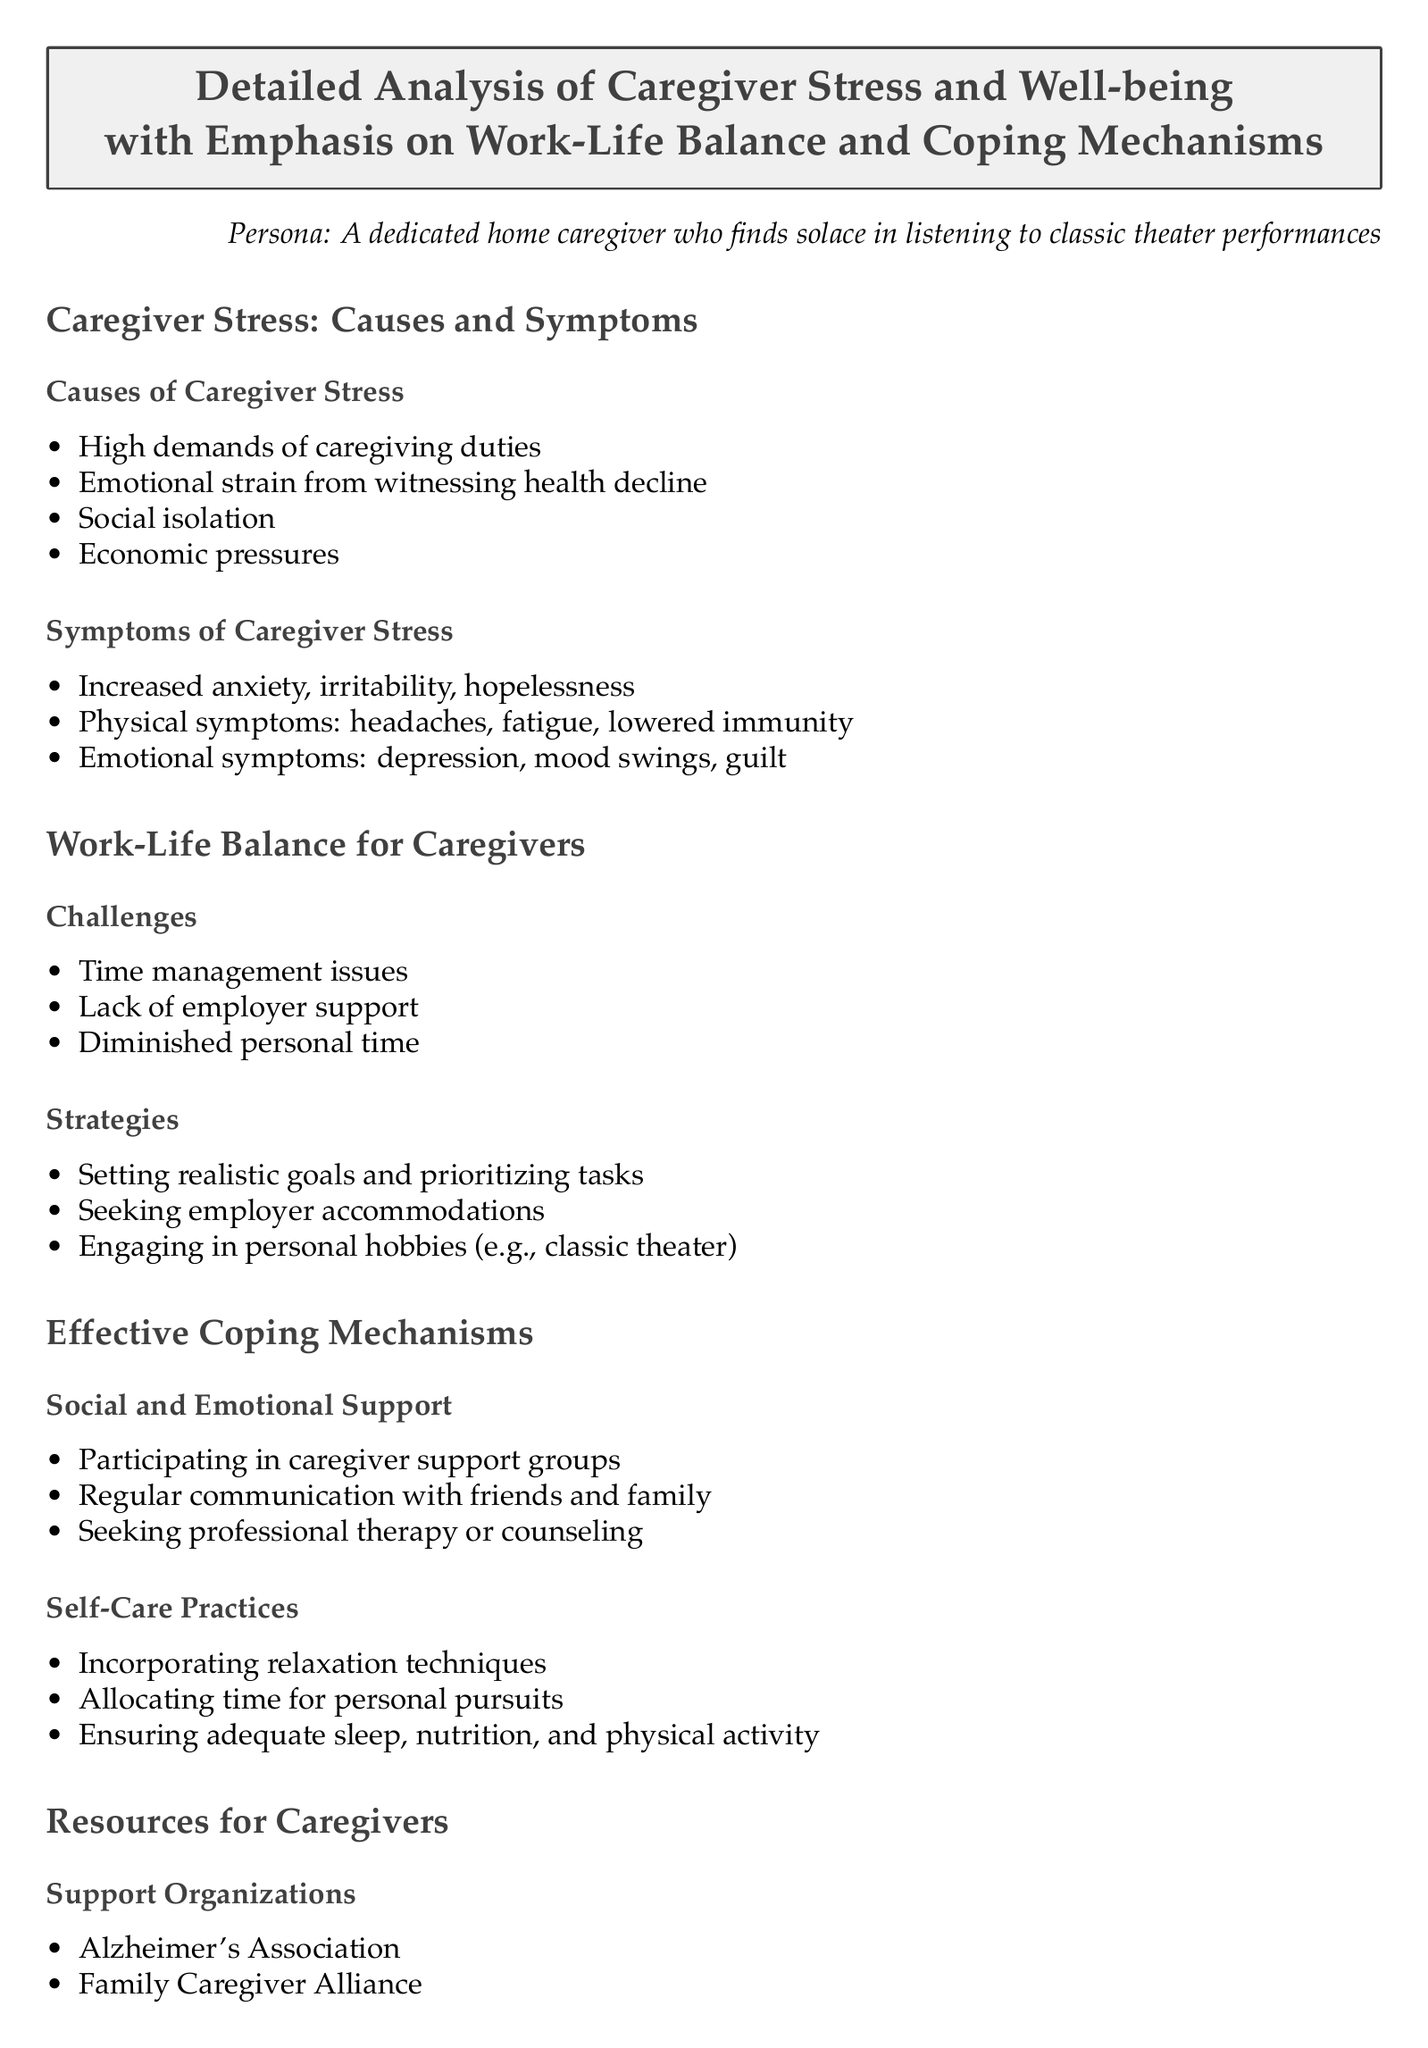What are some causes of caregiver stress? The document lists specific causes of caregiver stress, which include high demands of caregiving duties, emotional strain from witnessing health decline, social isolation, and economic pressures.
Answer: High demands, emotional strain, social isolation, economic pressures What are common symptoms of caregiver stress? The document details symptoms that range from increased anxiety and irritability to physical issues like headaches and emotional challenges including mood swings and guilt.
Answer: Anxiety, irritability, headaches, depression, mood swings, guilt What is one of the primary challenges in achieving work-life balance for caregivers? The document specifies several challenges, with time management issues highlighted as a significant hurdle for caregivers trying to balance their responsibilities.
Answer: Time management issues Name a strategy for improving work-life balance. The document suggests setting realistic goals and prioritizing tasks as strategies for caregivers to manage their time and responsibilities effectively.
Answer: Setting realistic goals What is a coping mechanism mentioned in the document? The document identifies several coping mechanisms, including engaging in personal hobbies, which help caregivers deal with stress and maintain balance.
Answer: Engaging in personal hobbies Which organization is listed as a support resource for caregivers? The document lists the Alzheimer's Association as a support organization that caregivers can turn to for assistance and resources.
Answer: Alzheimer's Association What type of tools are mentioned to assist caregivers? The document references caregiver apps, such as CareZone, as helpful tools that can provide practical support for managing caregiving tasks.
Answer: Caregiver apps How does the document suggest caregivers can gain social support? The document emphasizes that participating in caregiver support groups is a recommended way for caregivers to establish social connections and emotional support.
Answer: Caregiver support groups What is one self-care practice that is recommended? The document suggests incorporating relaxation techniques as a self-care practice for caregivers to relieve stress and improve overall well-being.
Answer: Incorporating relaxation techniques What are the emotional symptoms of caregiver stress? The symptoms listed in the document also include depression and mood swings, indicating the emotional toll caregiving can take.
Answer: Depression, mood swings 